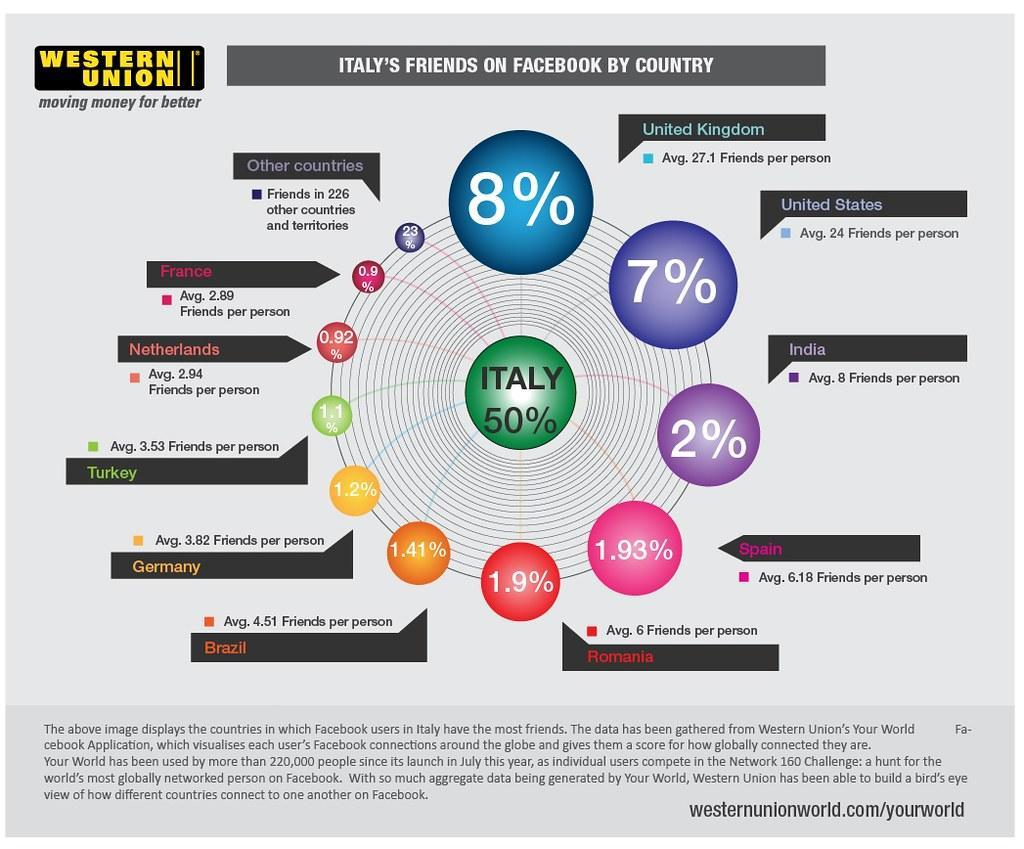What is the percentage of Facebook friends does Spain have in Italy?
Answer the question with a short phrase. 1.93% Which country has the eighth highest percentage of friends from Italy on Facebook? Turkey Which country has lowest percentage of friends from Italy on Facebook? France Which country has the second highest percentage of friends from Italy on Facebook? United States What is the percentage of Facebook friends does India have in Italy? 2% Which country has the sixth highest percentage of friends from Italy on Facebook? Brazil 